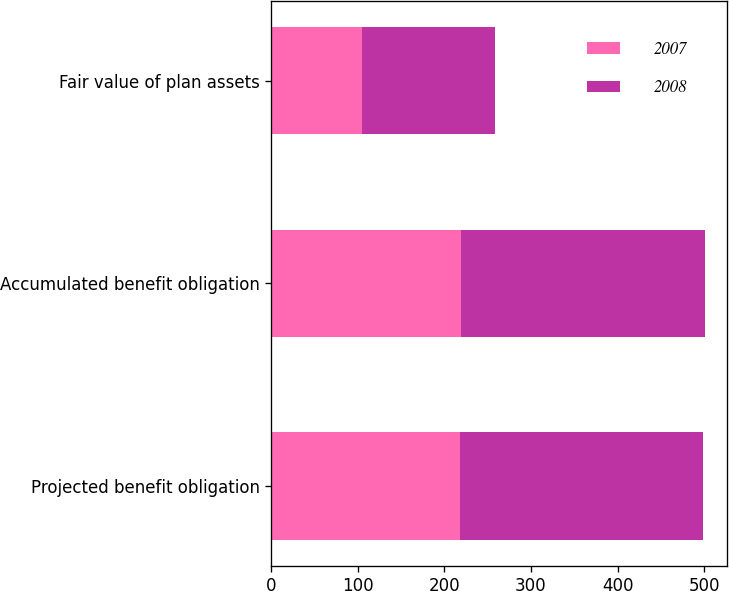Convert chart to OTSL. <chart><loc_0><loc_0><loc_500><loc_500><stacked_bar_chart><ecel><fcel>Projected benefit obligation<fcel>Accumulated benefit obligation<fcel>Fair value of plan assets<nl><fcel>2007<fcel>218.6<fcel>219.2<fcel>104.4<nl><fcel>2008<fcel>280.3<fcel>282.2<fcel>154.2<nl></chart> 